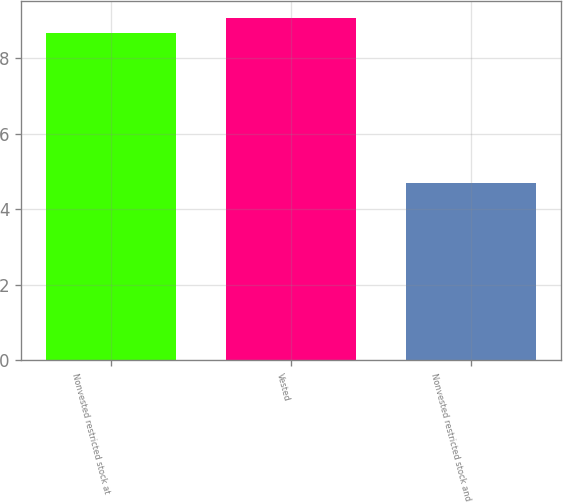<chart> <loc_0><loc_0><loc_500><loc_500><bar_chart><fcel>Nonvested restricted stock at<fcel>Vested<fcel>Nonvested restricted stock and<nl><fcel>8.67<fcel>9.07<fcel>4.7<nl></chart> 